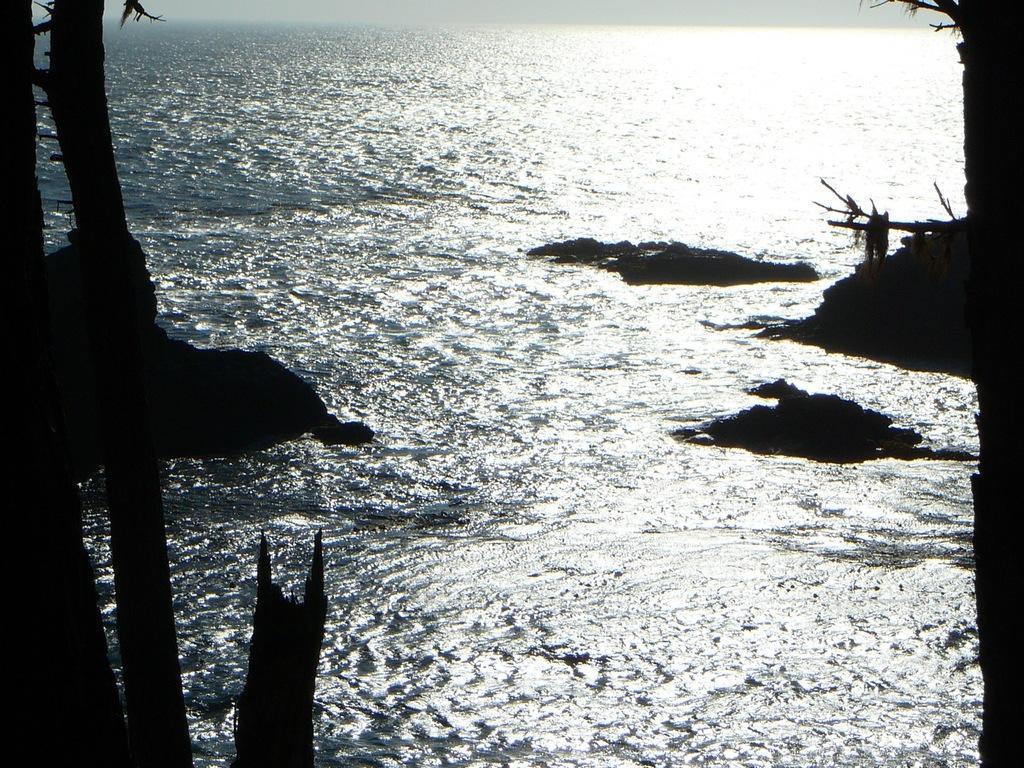Please provide a concise description of this image. At the bottom of the image we can see water, in the water we can see some stones and trees. 